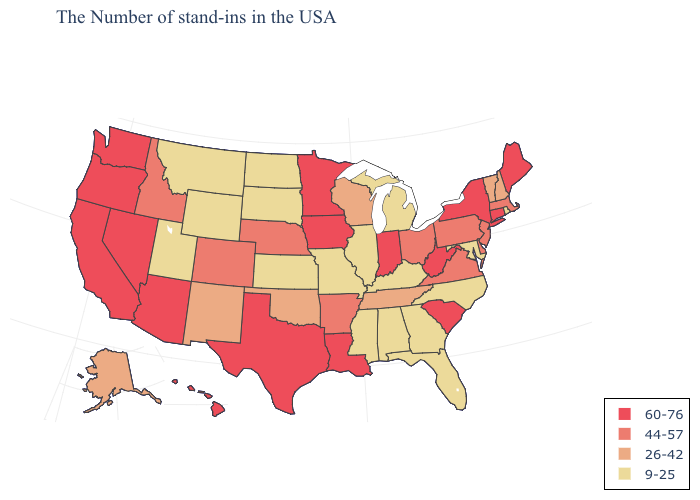What is the highest value in states that border Indiana?
Short answer required. 44-57. How many symbols are there in the legend?
Quick response, please. 4. Name the states that have a value in the range 26-42?
Answer briefly. New Hampshire, Vermont, Tennessee, Wisconsin, Oklahoma, New Mexico, Alaska. What is the lowest value in states that border Iowa?
Short answer required. 9-25. What is the highest value in the Northeast ?
Short answer required. 60-76. What is the value of Florida?
Be succinct. 9-25. What is the value of Ohio?
Answer briefly. 44-57. Name the states that have a value in the range 44-57?
Short answer required. Massachusetts, New Jersey, Delaware, Pennsylvania, Virginia, Ohio, Arkansas, Nebraska, Colorado, Idaho. What is the value of Maine?
Be succinct. 60-76. Name the states that have a value in the range 9-25?
Be succinct. Rhode Island, Maryland, North Carolina, Florida, Georgia, Michigan, Kentucky, Alabama, Illinois, Mississippi, Missouri, Kansas, South Dakota, North Dakota, Wyoming, Utah, Montana. Does Alabama have the highest value in the USA?
Write a very short answer. No. Does the map have missing data?
Be succinct. No. Which states have the highest value in the USA?
Be succinct. Maine, Connecticut, New York, South Carolina, West Virginia, Indiana, Louisiana, Minnesota, Iowa, Texas, Arizona, Nevada, California, Washington, Oregon, Hawaii. What is the highest value in the USA?
Short answer required. 60-76. Does Hawaii have the lowest value in the USA?
Keep it brief. No. 